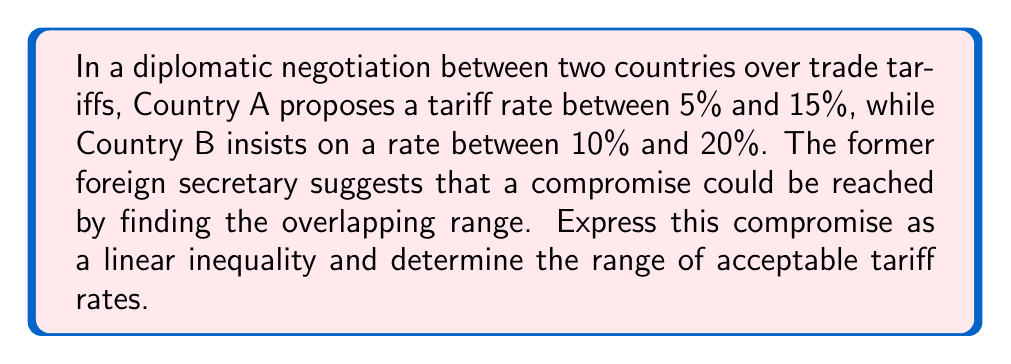Can you answer this question? 1) Let $x$ represent the tariff rate.

2) Country A's proposal can be expressed as:
   $5 \leq x \leq 15$

3) Country B's insistence can be expressed as:
   $10 \leq x \leq 20$

4) To find the compromise, we need to determine the overlap of these two inequalities:
   $\max(5, 10) \leq x \leq \min(15, 20)$

5) Simplifying:
   $10 \leq x \leq 15$

6) This can be written as a single linear inequality:
   $10 \leq x \leq 15$ or $-15 \leq -x \leq -10$

7) Adding these inequalities:
   $-5 \leq 0 \leq 5$

8) Since this is always true, our original inequality $10 \leq x \leq 15$ is the solution.

9) The range of acceptable tariff rates is therefore from 10% to 15%.
Answer: $10 \leq x \leq 15$, where $x$ is the tariff rate in percent. 